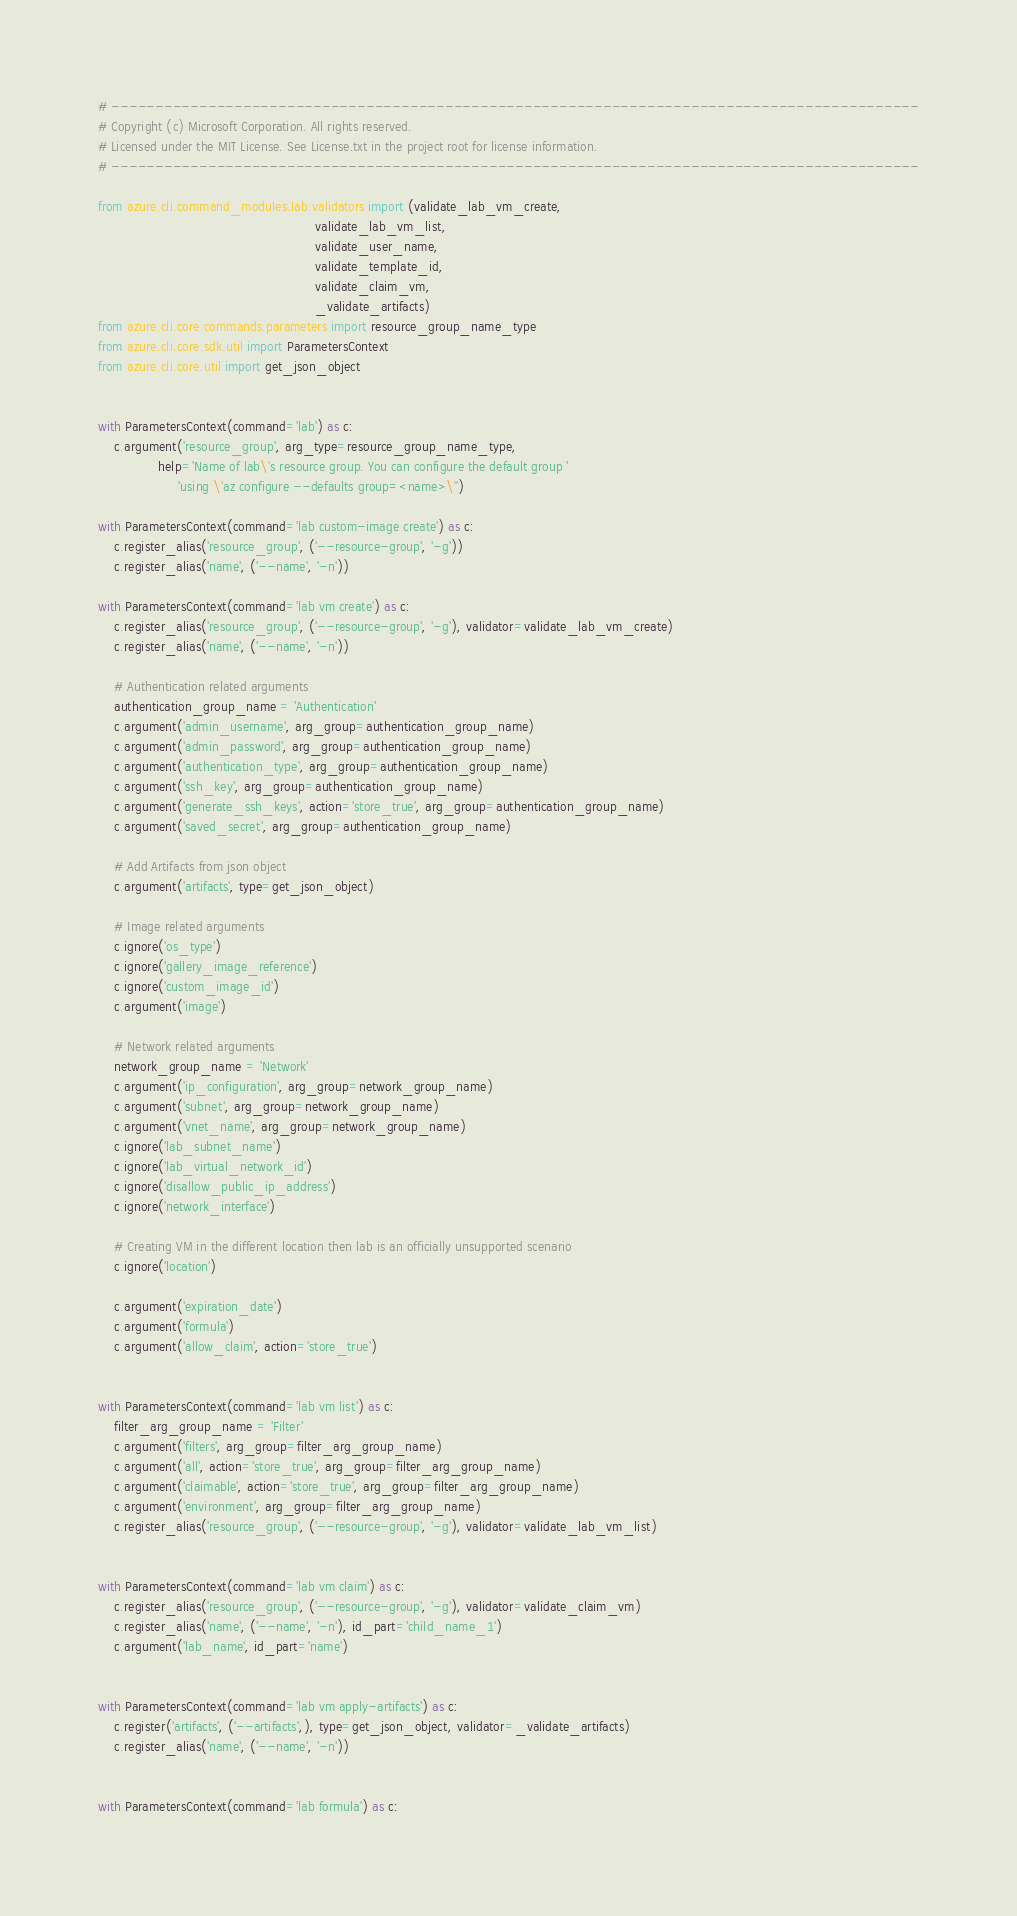Convert code to text. <code><loc_0><loc_0><loc_500><loc_500><_Python_># --------------------------------------------------------------------------------------------
# Copyright (c) Microsoft Corporation. All rights reserved.
# Licensed under the MIT License. See License.txt in the project root for license information.
# --------------------------------------------------------------------------------------------

from azure.cli.command_modules.lab.validators import (validate_lab_vm_create,
                                                      validate_lab_vm_list,
                                                      validate_user_name,
                                                      validate_template_id,
                                                      validate_claim_vm,
                                                      _validate_artifacts)
from azure.cli.core.commands.parameters import resource_group_name_type
from azure.cli.core.sdk.util import ParametersContext
from azure.cli.core.util import get_json_object


with ParametersContext(command='lab') as c:
    c.argument('resource_group', arg_type=resource_group_name_type,
               help='Name of lab\'s resource group. You can configure the default group '
                    'using \'az configure --defaults group=<name>\'')

with ParametersContext(command='lab custom-image create') as c:
    c.register_alias('resource_group', ('--resource-group', '-g'))
    c.register_alias('name', ('--name', '-n'))

with ParametersContext(command='lab vm create') as c:
    c.register_alias('resource_group', ('--resource-group', '-g'), validator=validate_lab_vm_create)
    c.register_alias('name', ('--name', '-n'))

    # Authentication related arguments
    authentication_group_name = 'Authentication'
    c.argument('admin_username', arg_group=authentication_group_name)
    c.argument('admin_password', arg_group=authentication_group_name)
    c.argument('authentication_type', arg_group=authentication_group_name)
    c.argument('ssh_key', arg_group=authentication_group_name)
    c.argument('generate_ssh_keys', action='store_true', arg_group=authentication_group_name)
    c.argument('saved_secret', arg_group=authentication_group_name)

    # Add Artifacts from json object
    c.argument('artifacts', type=get_json_object)

    # Image related arguments
    c.ignore('os_type')
    c.ignore('gallery_image_reference')
    c.ignore('custom_image_id')
    c.argument('image')

    # Network related arguments
    network_group_name = 'Network'
    c.argument('ip_configuration', arg_group=network_group_name)
    c.argument('subnet', arg_group=network_group_name)
    c.argument('vnet_name', arg_group=network_group_name)
    c.ignore('lab_subnet_name')
    c.ignore('lab_virtual_network_id')
    c.ignore('disallow_public_ip_address')
    c.ignore('network_interface')

    # Creating VM in the different location then lab is an officially unsupported scenario
    c.ignore('location')

    c.argument('expiration_date')
    c.argument('formula')
    c.argument('allow_claim', action='store_true')


with ParametersContext(command='lab vm list') as c:
    filter_arg_group_name = 'Filter'
    c.argument('filters', arg_group=filter_arg_group_name)
    c.argument('all', action='store_true', arg_group=filter_arg_group_name)
    c.argument('claimable', action='store_true', arg_group=filter_arg_group_name)
    c.argument('environment', arg_group=filter_arg_group_name)
    c.register_alias('resource_group', ('--resource-group', '-g'), validator=validate_lab_vm_list)


with ParametersContext(command='lab vm claim') as c:
    c.register_alias('resource_group', ('--resource-group', '-g'), validator=validate_claim_vm)
    c.register_alias('name', ('--name', '-n'), id_part='child_name_1')
    c.argument('lab_name', id_part='name')


with ParametersContext(command='lab vm apply-artifacts') as c:
    c.register('artifacts', ('--artifacts',), type=get_json_object, validator=_validate_artifacts)
    c.register_alias('name', ('--name', '-n'))


with ParametersContext(command='lab formula') as c:</code> 